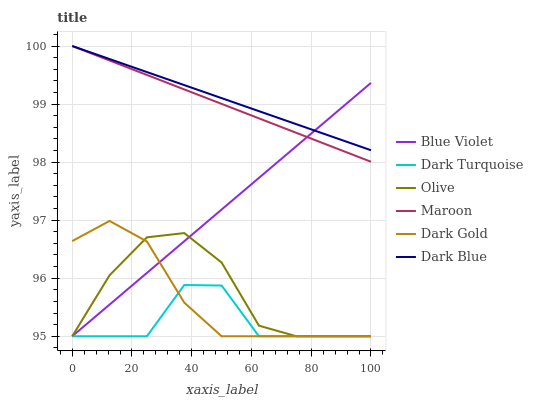Does Dark Turquoise have the minimum area under the curve?
Answer yes or no. Yes. Does Dark Blue have the maximum area under the curve?
Answer yes or no. Yes. Does Maroon have the minimum area under the curve?
Answer yes or no. No. Does Maroon have the maximum area under the curve?
Answer yes or no. No. Is Maroon the smoothest?
Answer yes or no. Yes. Is Dark Turquoise the roughest?
Answer yes or no. Yes. Is Dark Turquoise the smoothest?
Answer yes or no. No. Is Maroon the roughest?
Answer yes or no. No. Does Dark Gold have the lowest value?
Answer yes or no. Yes. Does Maroon have the lowest value?
Answer yes or no. No. Does Dark Blue have the highest value?
Answer yes or no. Yes. Does Dark Turquoise have the highest value?
Answer yes or no. No. Is Dark Turquoise less than Dark Blue?
Answer yes or no. Yes. Is Maroon greater than Dark Turquoise?
Answer yes or no. Yes. Does Dark Turquoise intersect Olive?
Answer yes or no. Yes. Is Dark Turquoise less than Olive?
Answer yes or no. No. Is Dark Turquoise greater than Olive?
Answer yes or no. No. Does Dark Turquoise intersect Dark Blue?
Answer yes or no. No. 